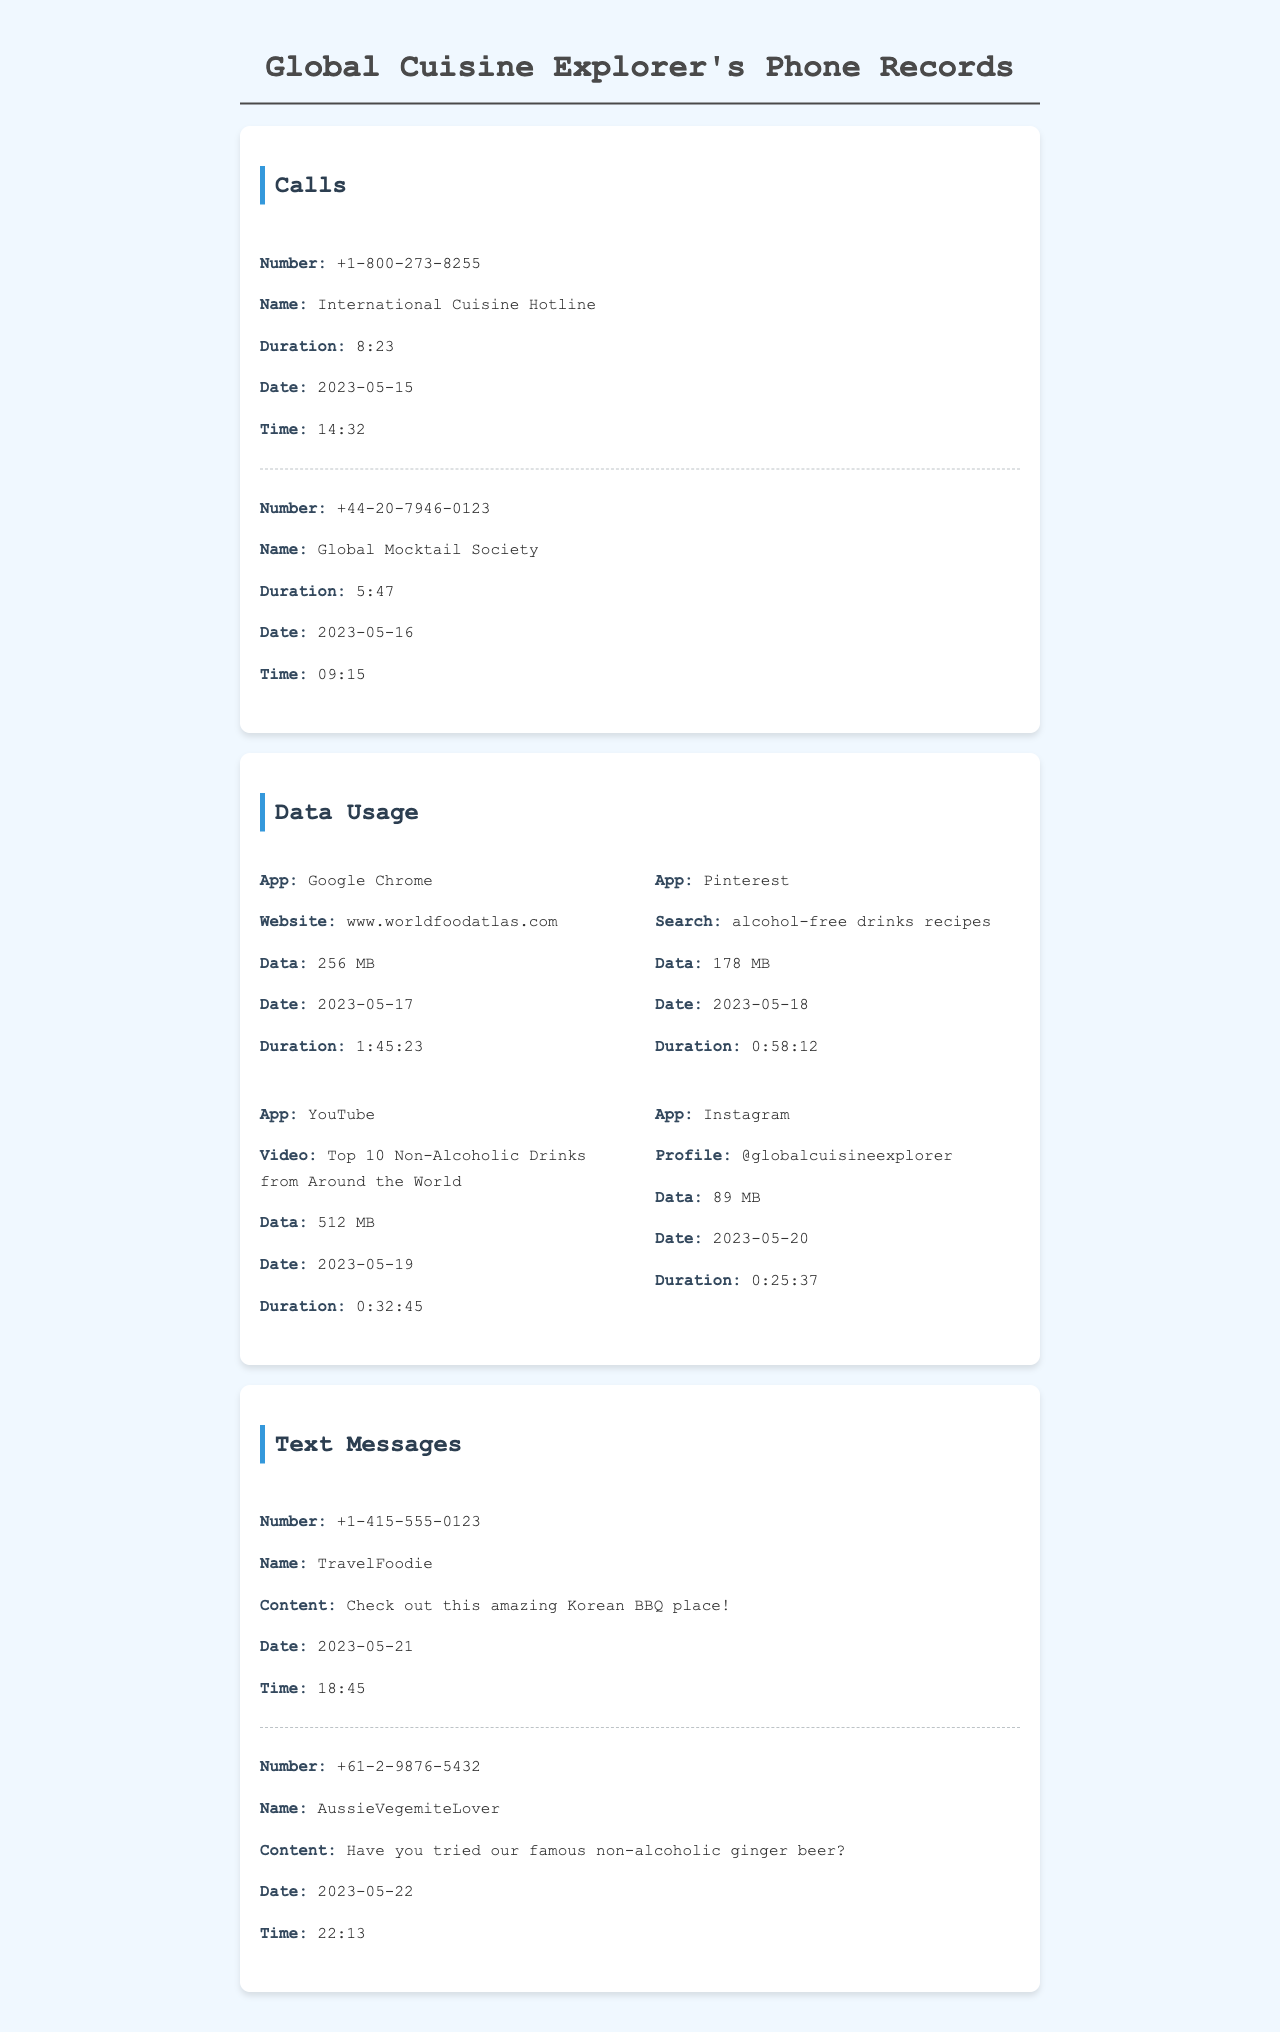What is the call duration for the International Cuisine Hotline? The call duration for the International Cuisine Hotline is stated in the document as 8 minutes and 23 seconds.
Answer: 8:23 What is the total data used for Google Chrome? The total data used for Google Chrome is specified in the document as 256 MB.
Answer: 256 MB Who sent the text message regarding Korean BBQ? The sender of the text message about Korean BBQ was TravelFoodie, as per the details in the document.
Answer: TravelFoodie On what date was the data usage for alcohol-free drinks recipes recorded? The date for the data usage related to alcohol-free drinks recipes is mentioned as May 18, 2023, in the data usage section.
Answer: 2023-05-18 What is the name of the society related to mocktails? The society related to mocktails is referred to as the Global Mocktail Society in the document's call records.
Answer: Global Mocktail Society Which app used the most data according to the document? The app that used the most data is YouTube, with a total of 512 MB recorded in the data usage section.
Answer: YouTube What profile was accessed on Instagram? The Instagram profile accessed was @globalcuisineexplorer, as noted in the document.
Answer: @globalcuisineexplorer How long was the YouTube video watched? The duration of the YouTube video watched is indicated as 32 minutes and 45 seconds in the data usage section.
Answer: 0:32:45 What type of drinks was mentioned in the text message about ginger beer? The text message mentions a famous non-alcoholic ginger beer, which relates to the context of the document's contents.
Answer: non-alcoholic ginger beer 